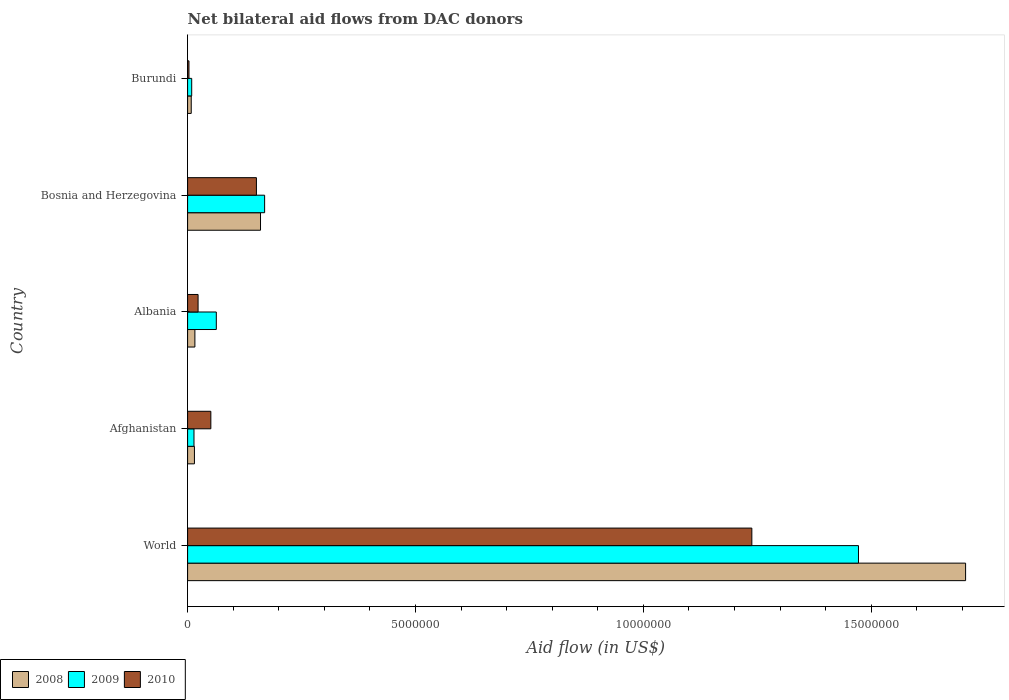How many different coloured bars are there?
Provide a short and direct response. 3. Are the number of bars per tick equal to the number of legend labels?
Offer a terse response. Yes. In how many cases, is the number of bars for a given country not equal to the number of legend labels?
Keep it short and to the point. 0. What is the net bilateral aid flow in 2008 in Afghanistan?
Offer a terse response. 1.50e+05. Across all countries, what is the maximum net bilateral aid flow in 2010?
Make the answer very short. 1.24e+07. In which country was the net bilateral aid flow in 2010 maximum?
Your response must be concise. World. In which country was the net bilateral aid flow in 2010 minimum?
Your response must be concise. Burundi. What is the total net bilateral aid flow in 2010 in the graph?
Keep it short and to the point. 1.47e+07. What is the difference between the net bilateral aid flow in 2010 in Burundi and the net bilateral aid flow in 2008 in World?
Provide a short and direct response. -1.70e+07. What is the average net bilateral aid flow in 2009 per country?
Your response must be concise. 3.45e+06. What is the difference between the net bilateral aid flow in 2010 and net bilateral aid flow in 2009 in Bosnia and Herzegovina?
Provide a short and direct response. -1.80e+05. In how many countries, is the net bilateral aid flow in 2009 greater than 3000000 US$?
Offer a very short reply. 1. What is the ratio of the net bilateral aid flow in 2010 in Afghanistan to that in Bosnia and Herzegovina?
Your response must be concise. 0.34. Is the difference between the net bilateral aid flow in 2010 in Afghanistan and Albania greater than the difference between the net bilateral aid flow in 2009 in Afghanistan and Albania?
Ensure brevity in your answer.  Yes. What is the difference between the highest and the second highest net bilateral aid flow in 2009?
Make the answer very short. 1.30e+07. What is the difference between the highest and the lowest net bilateral aid flow in 2008?
Offer a terse response. 1.70e+07. Is it the case that in every country, the sum of the net bilateral aid flow in 2008 and net bilateral aid flow in 2010 is greater than the net bilateral aid flow in 2009?
Ensure brevity in your answer.  No. How many bars are there?
Your response must be concise. 15. Are all the bars in the graph horizontal?
Offer a terse response. Yes. How many countries are there in the graph?
Make the answer very short. 5. What is the difference between two consecutive major ticks on the X-axis?
Your answer should be compact. 5.00e+06. Does the graph contain any zero values?
Make the answer very short. No. Does the graph contain grids?
Offer a very short reply. No. Where does the legend appear in the graph?
Offer a terse response. Bottom left. How are the legend labels stacked?
Your response must be concise. Horizontal. What is the title of the graph?
Give a very brief answer. Net bilateral aid flows from DAC donors. What is the label or title of the X-axis?
Provide a short and direct response. Aid flow (in US$). What is the Aid flow (in US$) in 2008 in World?
Give a very brief answer. 1.71e+07. What is the Aid flow (in US$) of 2009 in World?
Your answer should be compact. 1.47e+07. What is the Aid flow (in US$) in 2010 in World?
Your answer should be very brief. 1.24e+07. What is the Aid flow (in US$) of 2008 in Afghanistan?
Ensure brevity in your answer.  1.50e+05. What is the Aid flow (in US$) of 2010 in Afghanistan?
Provide a succinct answer. 5.10e+05. What is the Aid flow (in US$) of 2008 in Albania?
Provide a short and direct response. 1.60e+05. What is the Aid flow (in US$) in 2009 in Albania?
Offer a very short reply. 6.30e+05. What is the Aid flow (in US$) in 2008 in Bosnia and Herzegovina?
Keep it short and to the point. 1.60e+06. What is the Aid flow (in US$) of 2009 in Bosnia and Herzegovina?
Provide a short and direct response. 1.69e+06. What is the Aid flow (in US$) of 2010 in Bosnia and Herzegovina?
Keep it short and to the point. 1.51e+06. What is the Aid flow (in US$) in 2009 in Burundi?
Ensure brevity in your answer.  9.00e+04. Across all countries, what is the maximum Aid flow (in US$) of 2008?
Your response must be concise. 1.71e+07. Across all countries, what is the maximum Aid flow (in US$) of 2009?
Make the answer very short. 1.47e+07. Across all countries, what is the maximum Aid flow (in US$) of 2010?
Keep it short and to the point. 1.24e+07. Across all countries, what is the minimum Aid flow (in US$) of 2008?
Offer a very short reply. 8.00e+04. Across all countries, what is the minimum Aid flow (in US$) of 2009?
Keep it short and to the point. 9.00e+04. What is the total Aid flow (in US$) of 2008 in the graph?
Keep it short and to the point. 1.91e+07. What is the total Aid flow (in US$) in 2009 in the graph?
Keep it short and to the point. 1.73e+07. What is the total Aid flow (in US$) in 2010 in the graph?
Keep it short and to the point. 1.47e+07. What is the difference between the Aid flow (in US$) of 2008 in World and that in Afghanistan?
Keep it short and to the point. 1.69e+07. What is the difference between the Aid flow (in US$) in 2009 in World and that in Afghanistan?
Your answer should be very brief. 1.46e+07. What is the difference between the Aid flow (in US$) of 2010 in World and that in Afghanistan?
Provide a short and direct response. 1.19e+07. What is the difference between the Aid flow (in US$) in 2008 in World and that in Albania?
Offer a terse response. 1.69e+07. What is the difference between the Aid flow (in US$) of 2009 in World and that in Albania?
Offer a very short reply. 1.41e+07. What is the difference between the Aid flow (in US$) in 2010 in World and that in Albania?
Give a very brief answer. 1.22e+07. What is the difference between the Aid flow (in US$) of 2008 in World and that in Bosnia and Herzegovina?
Provide a succinct answer. 1.55e+07. What is the difference between the Aid flow (in US$) of 2009 in World and that in Bosnia and Herzegovina?
Ensure brevity in your answer.  1.30e+07. What is the difference between the Aid flow (in US$) in 2010 in World and that in Bosnia and Herzegovina?
Give a very brief answer. 1.09e+07. What is the difference between the Aid flow (in US$) of 2008 in World and that in Burundi?
Your answer should be compact. 1.70e+07. What is the difference between the Aid flow (in US$) of 2009 in World and that in Burundi?
Offer a terse response. 1.46e+07. What is the difference between the Aid flow (in US$) of 2010 in World and that in Burundi?
Offer a terse response. 1.24e+07. What is the difference between the Aid flow (in US$) in 2009 in Afghanistan and that in Albania?
Provide a succinct answer. -4.90e+05. What is the difference between the Aid flow (in US$) in 2008 in Afghanistan and that in Bosnia and Herzegovina?
Offer a very short reply. -1.45e+06. What is the difference between the Aid flow (in US$) in 2009 in Afghanistan and that in Bosnia and Herzegovina?
Provide a short and direct response. -1.55e+06. What is the difference between the Aid flow (in US$) of 2010 in Afghanistan and that in Bosnia and Herzegovina?
Provide a short and direct response. -1.00e+06. What is the difference between the Aid flow (in US$) of 2008 in Afghanistan and that in Burundi?
Your response must be concise. 7.00e+04. What is the difference between the Aid flow (in US$) of 2010 in Afghanistan and that in Burundi?
Your response must be concise. 4.80e+05. What is the difference between the Aid flow (in US$) of 2008 in Albania and that in Bosnia and Herzegovina?
Ensure brevity in your answer.  -1.44e+06. What is the difference between the Aid flow (in US$) in 2009 in Albania and that in Bosnia and Herzegovina?
Your answer should be very brief. -1.06e+06. What is the difference between the Aid flow (in US$) in 2010 in Albania and that in Bosnia and Herzegovina?
Your answer should be compact. -1.28e+06. What is the difference between the Aid flow (in US$) of 2009 in Albania and that in Burundi?
Your response must be concise. 5.40e+05. What is the difference between the Aid flow (in US$) in 2010 in Albania and that in Burundi?
Your response must be concise. 2.00e+05. What is the difference between the Aid flow (in US$) in 2008 in Bosnia and Herzegovina and that in Burundi?
Your answer should be compact. 1.52e+06. What is the difference between the Aid flow (in US$) in 2009 in Bosnia and Herzegovina and that in Burundi?
Give a very brief answer. 1.60e+06. What is the difference between the Aid flow (in US$) in 2010 in Bosnia and Herzegovina and that in Burundi?
Offer a very short reply. 1.48e+06. What is the difference between the Aid flow (in US$) in 2008 in World and the Aid flow (in US$) in 2009 in Afghanistan?
Your response must be concise. 1.69e+07. What is the difference between the Aid flow (in US$) in 2008 in World and the Aid flow (in US$) in 2010 in Afghanistan?
Provide a short and direct response. 1.66e+07. What is the difference between the Aid flow (in US$) of 2009 in World and the Aid flow (in US$) of 2010 in Afghanistan?
Make the answer very short. 1.42e+07. What is the difference between the Aid flow (in US$) of 2008 in World and the Aid flow (in US$) of 2009 in Albania?
Your answer should be compact. 1.64e+07. What is the difference between the Aid flow (in US$) in 2008 in World and the Aid flow (in US$) in 2010 in Albania?
Your response must be concise. 1.68e+07. What is the difference between the Aid flow (in US$) of 2009 in World and the Aid flow (in US$) of 2010 in Albania?
Provide a succinct answer. 1.45e+07. What is the difference between the Aid flow (in US$) of 2008 in World and the Aid flow (in US$) of 2009 in Bosnia and Herzegovina?
Your answer should be very brief. 1.54e+07. What is the difference between the Aid flow (in US$) in 2008 in World and the Aid flow (in US$) in 2010 in Bosnia and Herzegovina?
Your answer should be very brief. 1.56e+07. What is the difference between the Aid flow (in US$) of 2009 in World and the Aid flow (in US$) of 2010 in Bosnia and Herzegovina?
Ensure brevity in your answer.  1.32e+07. What is the difference between the Aid flow (in US$) in 2008 in World and the Aid flow (in US$) in 2009 in Burundi?
Offer a very short reply. 1.70e+07. What is the difference between the Aid flow (in US$) of 2008 in World and the Aid flow (in US$) of 2010 in Burundi?
Provide a succinct answer. 1.70e+07. What is the difference between the Aid flow (in US$) in 2009 in World and the Aid flow (in US$) in 2010 in Burundi?
Ensure brevity in your answer.  1.47e+07. What is the difference between the Aid flow (in US$) of 2008 in Afghanistan and the Aid flow (in US$) of 2009 in Albania?
Provide a succinct answer. -4.80e+05. What is the difference between the Aid flow (in US$) in 2008 in Afghanistan and the Aid flow (in US$) in 2010 in Albania?
Ensure brevity in your answer.  -8.00e+04. What is the difference between the Aid flow (in US$) in 2009 in Afghanistan and the Aid flow (in US$) in 2010 in Albania?
Provide a succinct answer. -9.00e+04. What is the difference between the Aid flow (in US$) of 2008 in Afghanistan and the Aid flow (in US$) of 2009 in Bosnia and Herzegovina?
Your answer should be compact. -1.54e+06. What is the difference between the Aid flow (in US$) of 2008 in Afghanistan and the Aid flow (in US$) of 2010 in Bosnia and Herzegovina?
Provide a succinct answer. -1.36e+06. What is the difference between the Aid flow (in US$) in 2009 in Afghanistan and the Aid flow (in US$) in 2010 in Bosnia and Herzegovina?
Make the answer very short. -1.37e+06. What is the difference between the Aid flow (in US$) in 2008 in Afghanistan and the Aid flow (in US$) in 2009 in Burundi?
Your response must be concise. 6.00e+04. What is the difference between the Aid flow (in US$) of 2008 in Afghanistan and the Aid flow (in US$) of 2010 in Burundi?
Your answer should be compact. 1.20e+05. What is the difference between the Aid flow (in US$) in 2008 in Albania and the Aid flow (in US$) in 2009 in Bosnia and Herzegovina?
Keep it short and to the point. -1.53e+06. What is the difference between the Aid flow (in US$) of 2008 in Albania and the Aid flow (in US$) of 2010 in Bosnia and Herzegovina?
Keep it short and to the point. -1.35e+06. What is the difference between the Aid flow (in US$) of 2009 in Albania and the Aid flow (in US$) of 2010 in Bosnia and Herzegovina?
Your response must be concise. -8.80e+05. What is the difference between the Aid flow (in US$) of 2008 in Albania and the Aid flow (in US$) of 2010 in Burundi?
Give a very brief answer. 1.30e+05. What is the difference between the Aid flow (in US$) of 2009 in Albania and the Aid flow (in US$) of 2010 in Burundi?
Offer a terse response. 6.00e+05. What is the difference between the Aid flow (in US$) in 2008 in Bosnia and Herzegovina and the Aid flow (in US$) in 2009 in Burundi?
Keep it short and to the point. 1.51e+06. What is the difference between the Aid flow (in US$) in 2008 in Bosnia and Herzegovina and the Aid flow (in US$) in 2010 in Burundi?
Make the answer very short. 1.57e+06. What is the difference between the Aid flow (in US$) in 2009 in Bosnia and Herzegovina and the Aid flow (in US$) in 2010 in Burundi?
Provide a short and direct response. 1.66e+06. What is the average Aid flow (in US$) of 2008 per country?
Provide a succinct answer. 3.81e+06. What is the average Aid flow (in US$) in 2009 per country?
Provide a succinct answer. 3.45e+06. What is the average Aid flow (in US$) in 2010 per country?
Offer a terse response. 2.93e+06. What is the difference between the Aid flow (in US$) of 2008 and Aid flow (in US$) of 2009 in World?
Your answer should be very brief. 2.35e+06. What is the difference between the Aid flow (in US$) of 2008 and Aid flow (in US$) of 2010 in World?
Ensure brevity in your answer.  4.69e+06. What is the difference between the Aid flow (in US$) in 2009 and Aid flow (in US$) in 2010 in World?
Your answer should be very brief. 2.34e+06. What is the difference between the Aid flow (in US$) in 2008 and Aid flow (in US$) in 2010 in Afghanistan?
Ensure brevity in your answer.  -3.60e+05. What is the difference between the Aid flow (in US$) in 2009 and Aid flow (in US$) in 2010 in Afghanistan?
Provide a succinct answer. -3.70e+05. What is the difference between the Aid flow (in US$) of 2008 and Aid flow (in US$) of 2009 in Albania?
Make the answer very short. -4.70e+05. What is the difference between the Aid flow (in US$) in 2008 and Aid flow (in US$) in 2010 in Albania?
Your answer should be compact. -7.00e+04. What is the difference between the Aid flow (in US$) in 2009 and Aid flow (in US$) in 2010 in Albania?
Your response must be concise. 4.00e+05. What is the difference between the Aid flow (in US$) of 2008 and Aid flow (in US$) of 2009 in Bosnia and Herzegovina?
Offer a terse response. -9.00e+04. What is the difference between the Aid flow (in US$) of 2008 and Aid flow (in US$) of 2010 in Bosnia and Herzegovina?
Offer a very short reply. 9.00e+04. What is the difference between the Aid flow (in US$) in 2009 and Aid flow (in US$) in 2010 in Bosnia and Herzegovina?
Offer a terse response. 1.80e+05. What is the difference between the Aid flow (in US$) of 2008 and Aid flow (in US$) of 2010 in Burundi?
Ensure brevity in your answer.  5.00e+04. What is the ratio of the Aid flow (in US$) of 2008 in World to that in Afghanistan?
Make the answer very short. 113.8. What is the ratio of the Aid flow (in US$) in 2009 in World to that in Afghanistan?
Your response must be concise. 105.14. What is the ratio of the Aid flow (in US$) in 2010 in World to that in Afghanistan?
Provide a succinct answer. 24.27. What is the ratio of the Aid flow (in US$) of 2008 in World to that in Albania?
Keep it short and to the point. 106.69. What is the ratio of the Aid flow (in US$) in 2009 in World to that in Albania?
Keep it short and to the point. 23.37. What is the ratio of the Aid flow (in US$) of 2010 in World to that in Albania?
Give a very brief answer. 53.83. What is the ratio of the Aid flow (in US$) of 2008 in World to that in Bosnia and Herzegovina?
Provide a short and direct response. 10.67. What is the ratio of the Aid flow (in US$) in 2009 in World to that in Bosnia and Herzegovina?
Your answer should be compact. 8.71. What is the ratio of the Aid flow (in US$) of 2010 in World to that in Bosnia and Herzegovina?
Provide a short and direct response. 8.2. What is the ratio of the Aid flow (in US$) in 2008 in World to that in Burundi?
Give a very brief answer. 213.38. What is the ratio of the Aid flow (in US$) of 2009 in World to that in Burundi?
Offer a very short reply. 163.56. What is the ratio of the Aid flow (in US$) in 2010 in World to that in Burundi?
Provide a short and direct response. 412.67. What is the ratio of the Aid flow (in US$) of 2008 in Afghanistan to that in Albania?
Provide a short and direct response. 0.94. What is the ratio of the Aid flow (in US$) in 2009 in Afghanistan to that in Albania?
Provide a succinct answer. 0.22. What is the ratio of the Aid flow (in US$) of 2010 in Afghanistan to that in Albania?
Offer a terse response. 2.22. What is the ratio of the Aid flow (in US$) in 2008 in Afghanistan to that in Bosnia and Herzegovina?
Offer a very short reply. 0.09. What is the ratio of the Aid flow (in US$) of 2009 in Afghanistan to that in Bosnia and Herzegovina?
Keep it short and to the point. 0.08. What is the ratio of the Aid flow (in US$) of 2010 in Afghanistan to that in Bosnia and Herzegovina?
Your response must be concise. 0.34. What is the ratio of the Aid flow (in US$) of 2008 in Afghanistan to that in Burundi?
Keep it short and to the point. 1.88. What is the ratio of the Aid flow (in US$) in 2009 in Afghanistan to that in Burundi?
Your response must be concise. 1.56. What is the ratio of the Aid flow (in US$) of 2010 in Afghanistan to that in Burundi?
Provide a short and direct response. 17. What is the ratio of the Aid flow (in US$) in 2008 in Albania to that in Bosnia and Herzegovina?
Ensure brevity in your answer.  0.1. What is the ratio of the Aid flow (in US$) in 2009 in Albania to that in Bosnia and Herzegovina?
Keep it short and to the point. 0.37. What is the ratio of the Aid flow (in US$) of 2010 in Albania to that in Bosnia and Herzegovina?
Offer a terse response. 0.15. What is the ratio of the Aid flow (in US$) in 2008 in Albania to that in Burundi?
Make the answer very short. 2. What is the ratio of the Aid flow (in US$) of 2009 in Albania to that in Burundi?
Offer a terse response. 7. What is the ratio of the Aid flow (in US$) of 2010 in Albania to that in Burundi?
Provide a succinct answer. 7.67. What is the ratio of the Aid flow (in US$) in 2008 in Bosnia and Herzegovina to that in Burundi?
Offer a terse response. 20. What is the ratio of the Aid flow (in US$) of 2009 in Bosnia and Herzegovina to that in Burundi?
Provide a succinct answer. 18.78. What is the ratio of the Aid flow (in US$) in 2010 in Bosnia and Herzegovina to that in Burundi?
Make the answer very short. 50.33. What is the difference between the highest and the second highest Aid flow (in US$) in 2008?
Provide a short and direct response. 1.55e+07. What is the difference between the highest and the second highest Aid flow (in US$) in 2009?
Your answer should be very brief. 1.30e+07. What is the difference between the highest and the second highest Aid flow (in US$) of 2010?
Your answer should be compact. 1.09e+07. What is the difference between the highest and the lowest Aid flow (in US$) in 2008?
Offer a terse response. 1.70e+07. What is the difference between the highest and the lowest Aid flow (in US$) in 2009?
Offer a terse response. 1.46e+07. What is the difference between the highest and the lowest Aid flow (in US$) in 2010?
Keep it short and to the point. 1.24e+07. 